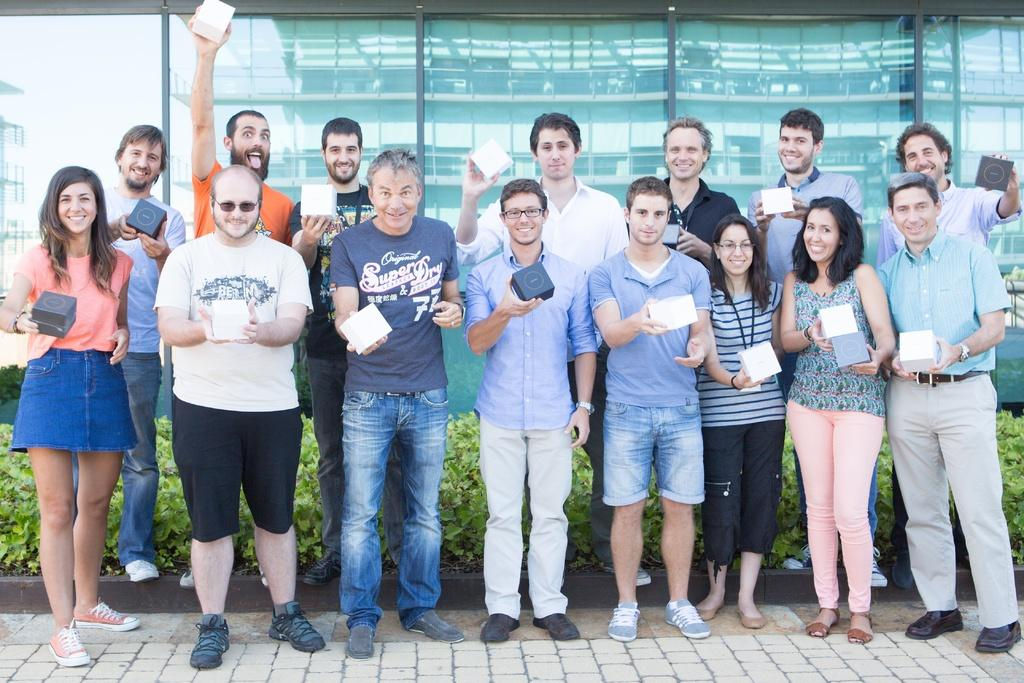How many people are in the image? There are persons in the image, but the exact number is not specified. What are the persons wearing? The persons are wearing clothes. What are the persons holding in their hands? The persons are holding boxes with their hands. What is behind the persons in the image? The persons are standing in front of plants. What can be seen in the background of the image? There is a glass wall in the background of the image. Can you tell me how many goldfish are swimming in the glass wall in the image? There are no goldfish present in the image; the glass wall is in the background, and the image focuses on the persons and their surroundings. 